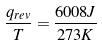Convert formula to latex. <formula><loc_0><loc_0><loc_500><loc_500>\frac { q _ { r e v } } { T } = \frac { 6 0 0 8 J } { 2 7 3 K }</formula> 